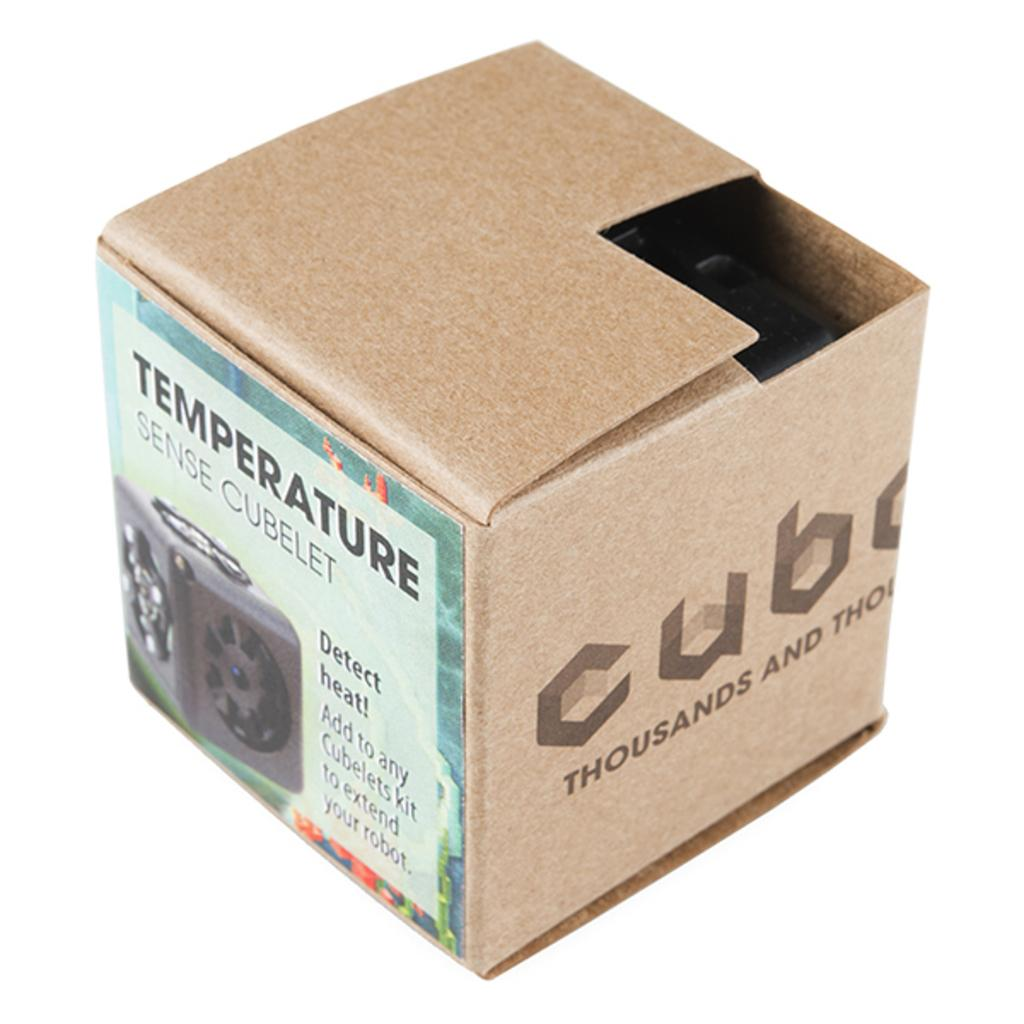What is the main object in the image? There is a shipping box in the image. What is on the shipping box? There is a poster in light green color on the box. What can be seen on the poster? There is text written on the poster. What is the color of the background in the image? The background of the image is white in color. What type of whip is being used to create the text on the poster? There is no whip present in the image, and the text on the poster is not created using a whip. 